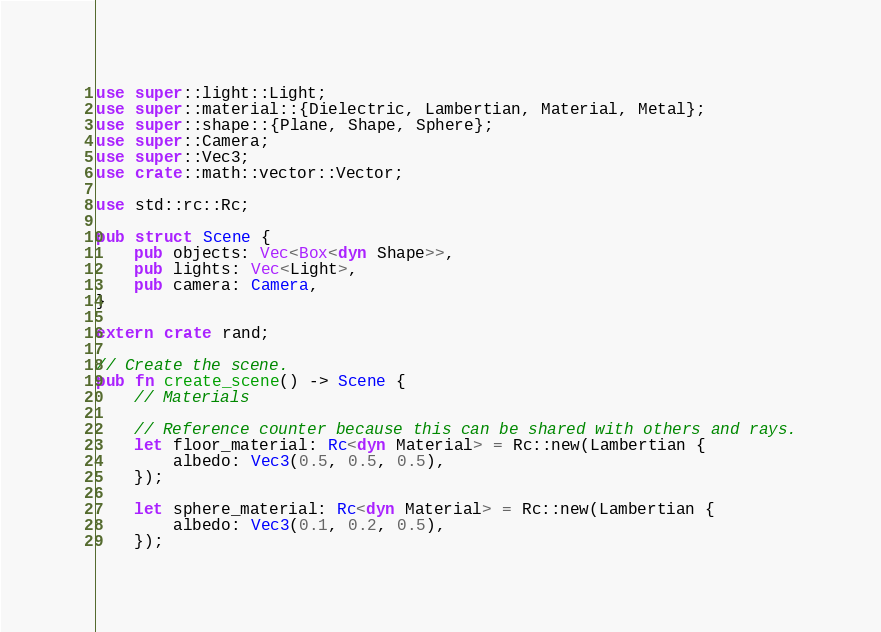Convert code to text. <code><loc_0><loc_0><loc_500><loc_500><_Rust_>use super::light::Light;
use super::material::{Dielectric, Lambertian, Material, Metal};
use super::shape::{Plane, Shape, Sphere};
use super::Camera;
use super::Vec3;
use crate::math::vector::Vector;

use std::rc::Rc;

pub struct Scene {
    pub objects: Vec<Box<dyn Shape>>,
    pub lights: Vec<Light>,
    pub camera: Camera,
}

extern crate rand;

// Create the scene.
pub fn create_scene() -> Scene {
    // Materials

    // Reference counter because this can be shared with others and rays.
    let floor_material: Rc<dyn Material> = Rc::new(Lambertian {
        albedo: Vec3(0.5, 0.5, 0.5),
    });

    let sphere_material: Rc<dyn Material> = Rc::new(Lambertian {
        albedo: Vec3(0.1, 0.2, 0.5),
    });
</code> 